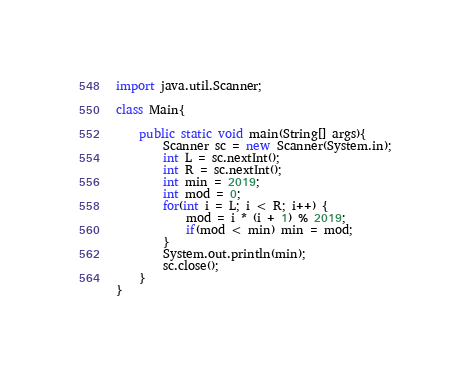Convert code to text. <code><loc_0><loc_0><loc_500><loc_500><_Java_>import java.util.Scanner;

class Main{
	
	public static void main(String[] args){
		Scanner sc = new Scanner(System.in);
		int L = sc.nextInt();
		int R = sc.nextInt();
		int min = 2019;
		int mod = 0;
		for(int i = L; i < R; i++) {
			mod = i * (i + 1) % 2019;
			if(mod < min) min = mod;
		}
		System.out.println(min);
		sc.close();
	}
}</code> 